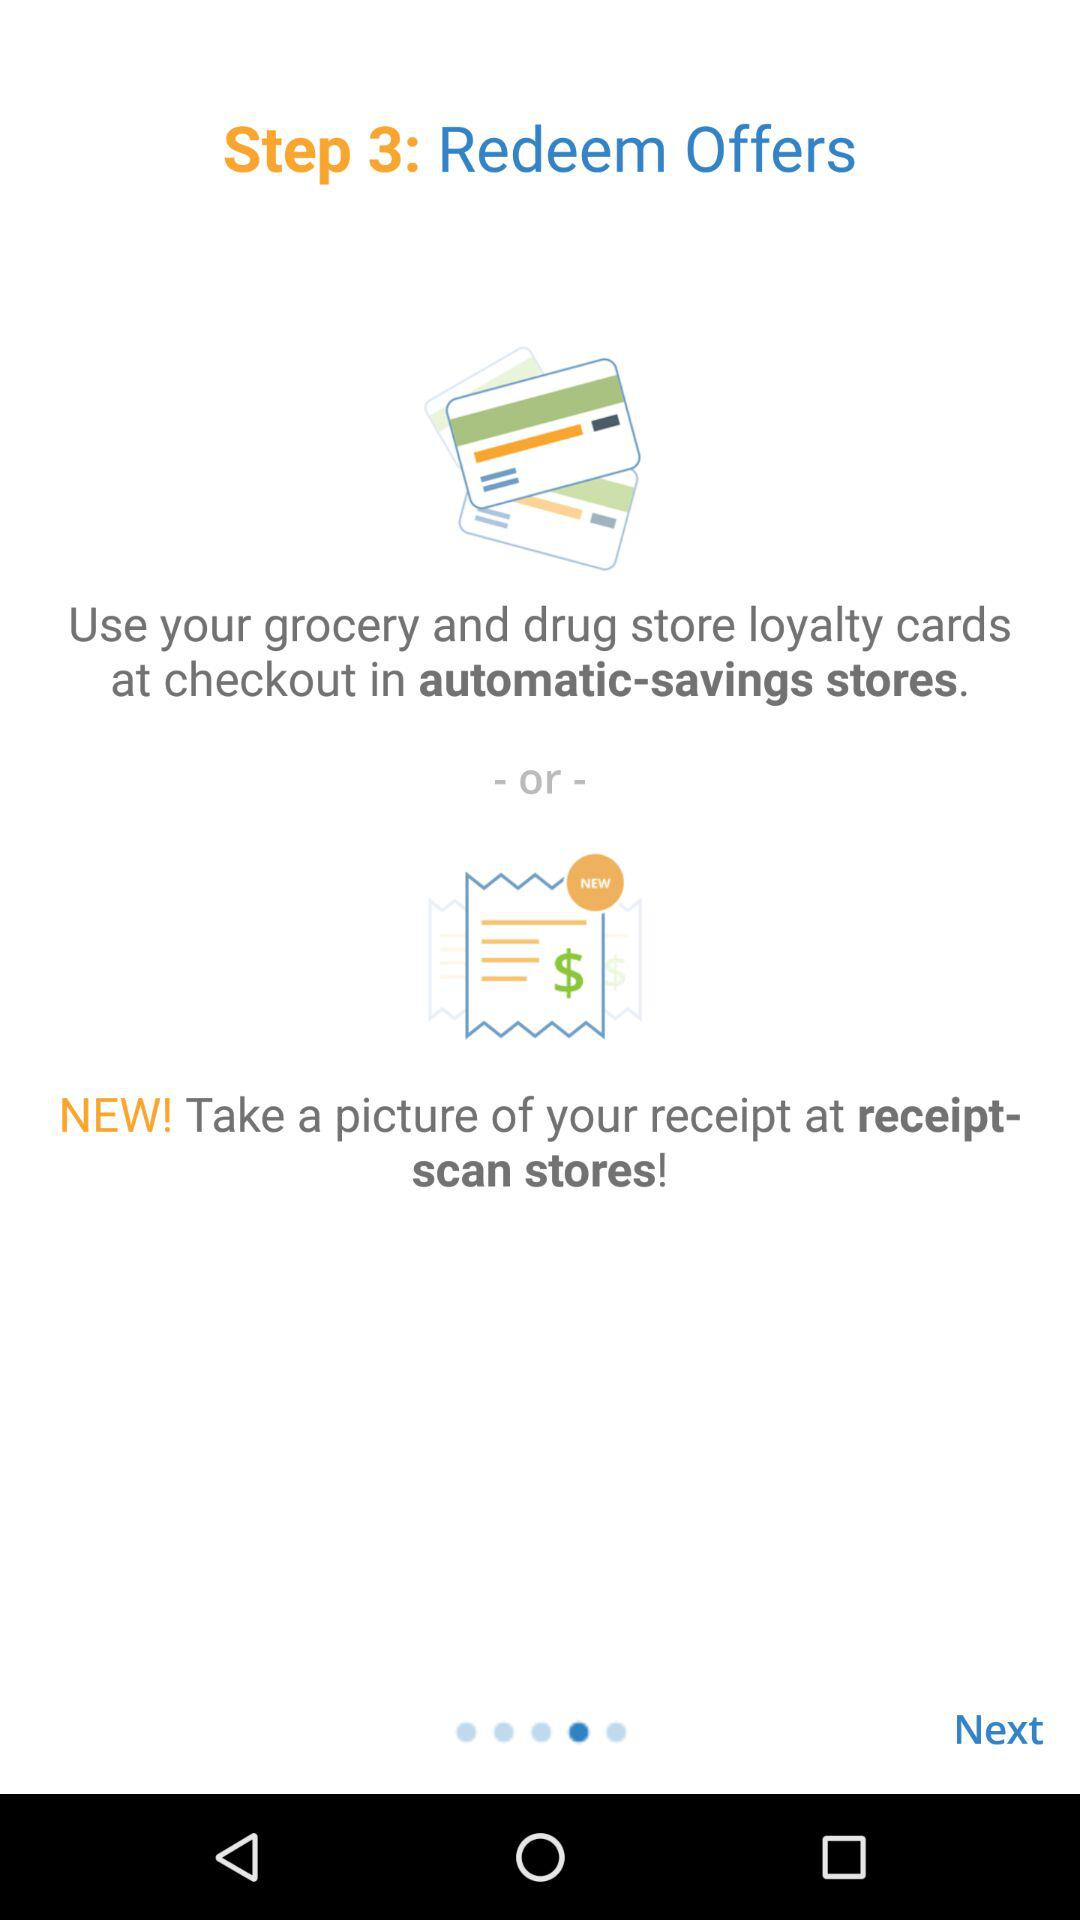How many options are there to redeem offers?
Answer the question using a single word or phrase. 2 